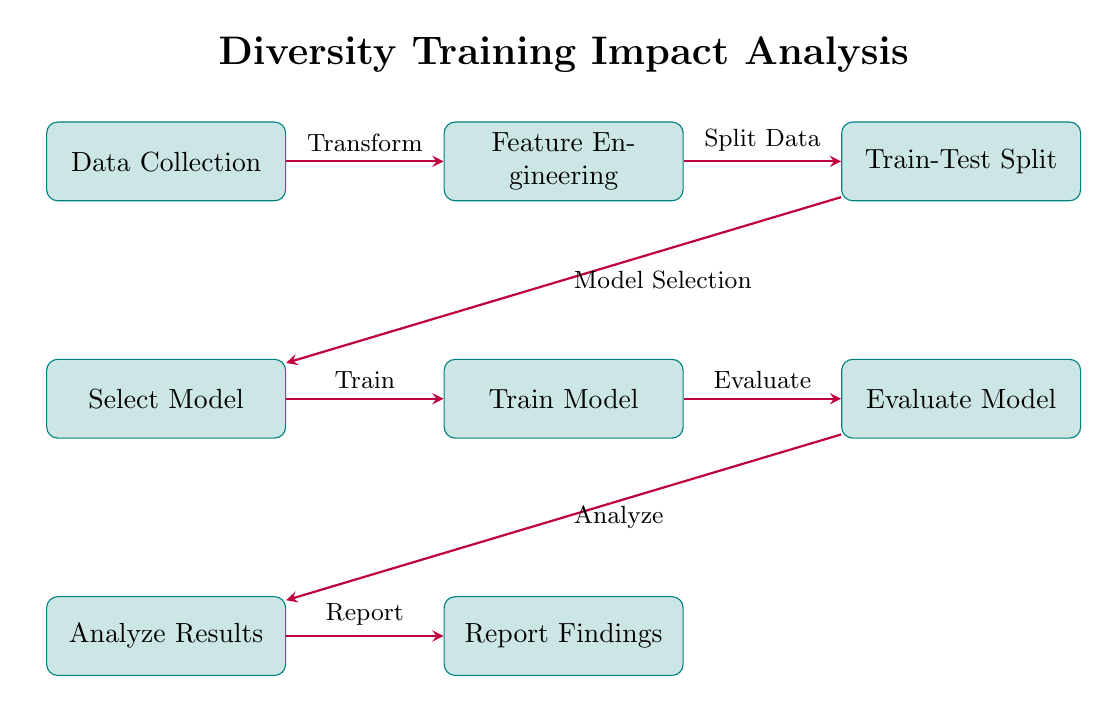What is the first step in the diagram? The first step in the diagram is the "Data Collection" process, which is positioned at the top left of the diagram.
Answer: Data Collection How many processes are shown in the diagram? The diagram contains a total of seven processes, including "Data Collection," "Feature Engineering," "Train-Test Split," "Select Model," "Train Model," "Evaluate Model," and "Analyze Results."
Answer: Seven What is the relationship between "Train Model" and "Evaluate Model"? The relationship between "Train Model" and "Evaluate Model" is that the evaluation occurs after the model has been trained. The arrow indicates that the "Train Model" process flows into the "Evaluate Model" process.
Answer: Train Which process is directly below "Select Model"? The process directly below "Select Model" is "Analyze Results," which illustrates a sequence where results are analyzed after the model selection.
Answer: Analyze Results What action is taken after the "Evaluate Model" process? After the "Evaluate Model" process, the action taken is to "Analyze Results," indicating that the evaluation is followed by an analysis step to interpret the model's performance.
Answer: Analyze What transformation occurs between "Data Collection" and "Feature Engineering"? The transformation that occurs between "Data Collection" and "Feature Engineering" is described as "Transform," indicating that the collected data undergoes some form of transformation before feature engineering.
Answer: Transform In which direction does data flow from "Feature Engineering"? The data flows to the right from "Feature Engineering" to "Train-Test Split," showcasing a sequential progression in the analysis pipeline.
Answer: Right After "Analyze Results," which process follows next? After "Analyze Results," the next process is "Report Findings," indicating the final step where findings are reported after analysis.
Answer: Report Findings 